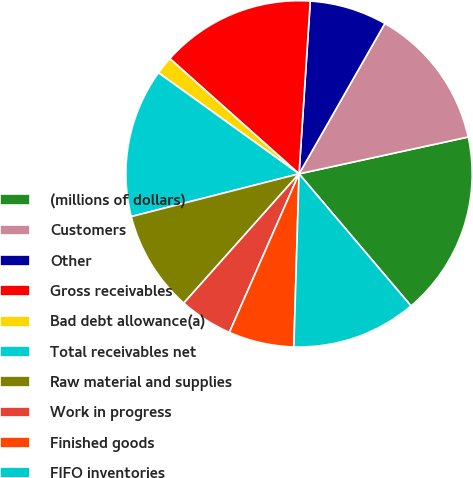Convert chart. <chart><loc_0><loc_0><loc_500><loc_500><pie_chart><fcel>(millions of dollars)<fcel>Customers<fcel>Other<fcel>Gross receivables<fcel>Bad debt allowance(a)<fcel>Total receivables net<fcel>Raw material and supplies<fcel>Work in progress<fcel>Finished goods<fcel>FIFO inventories<nl><fcel>17.22%<fcel>13.33%<fcel>7.22%<fcel>14.44%<fcel>1.67%<fcel>13.89%<fcel>9.44%<fcel>5.0%<fcel>6.11%<fcel>11.67%<nl></chart> 